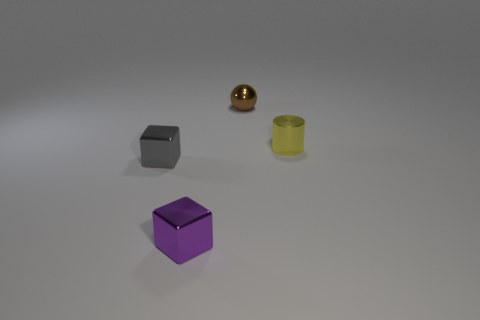What can you infer about the image's purpose? This image appears to be a computer-generated rendering, commonly used in visual effect studies or material demonstrations. It could be used to showcase object textures, lighting effects, or even as a sample rendering in software tutorials. 